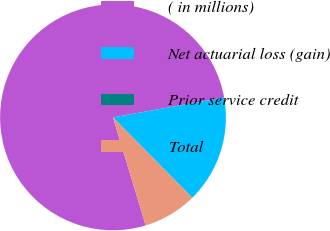Convert chart. <chart><loc_0><loc_0><loc_500><loc_500><pie_chart><fcel>( in millions)<fcel>Net actuarial loss (gain)<fcel>Prior service credit<fcel>Total<nl><fcel>76.86%<fcel>15.4%<fcel>0.03%<fcel>7.71%<nl></chart> 